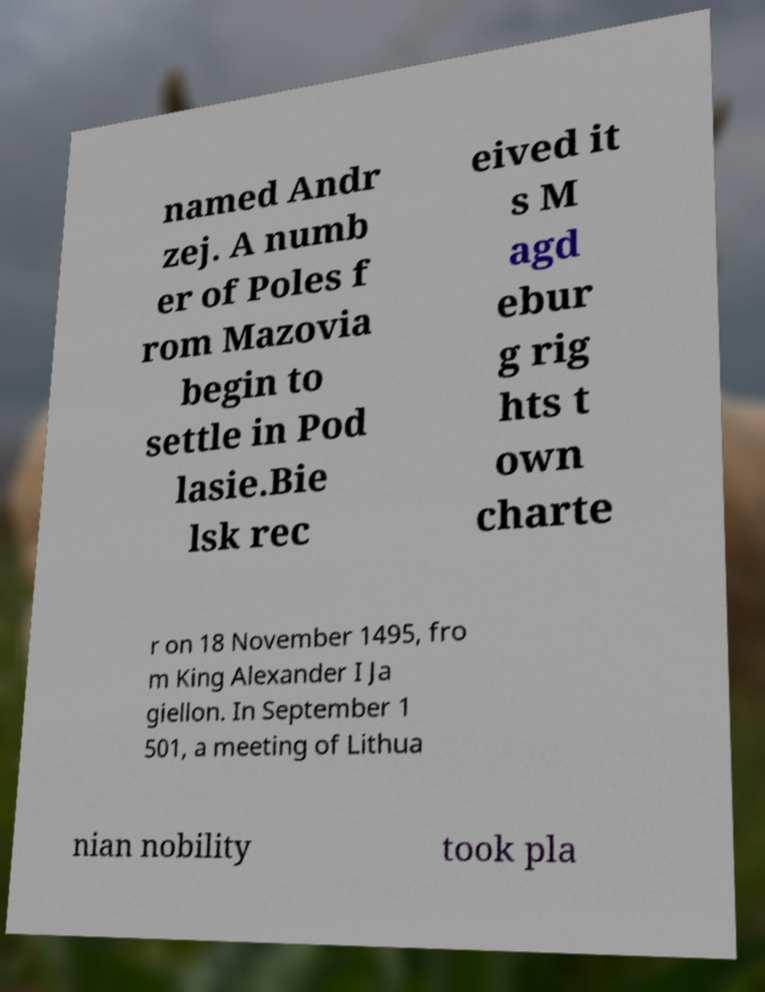Please identify and transcribe the text found in this image. named Andr zej. A numb er of Poles f rom Mazovia begin to settle in Pod lasie.Bie lsk rec eived it s M agd ebur g rig hts t own charte r on 18 November 1495, fro m King Alexander I Ja giellon. In September 1 501, a meeting of Lithua nian nobility took pla 